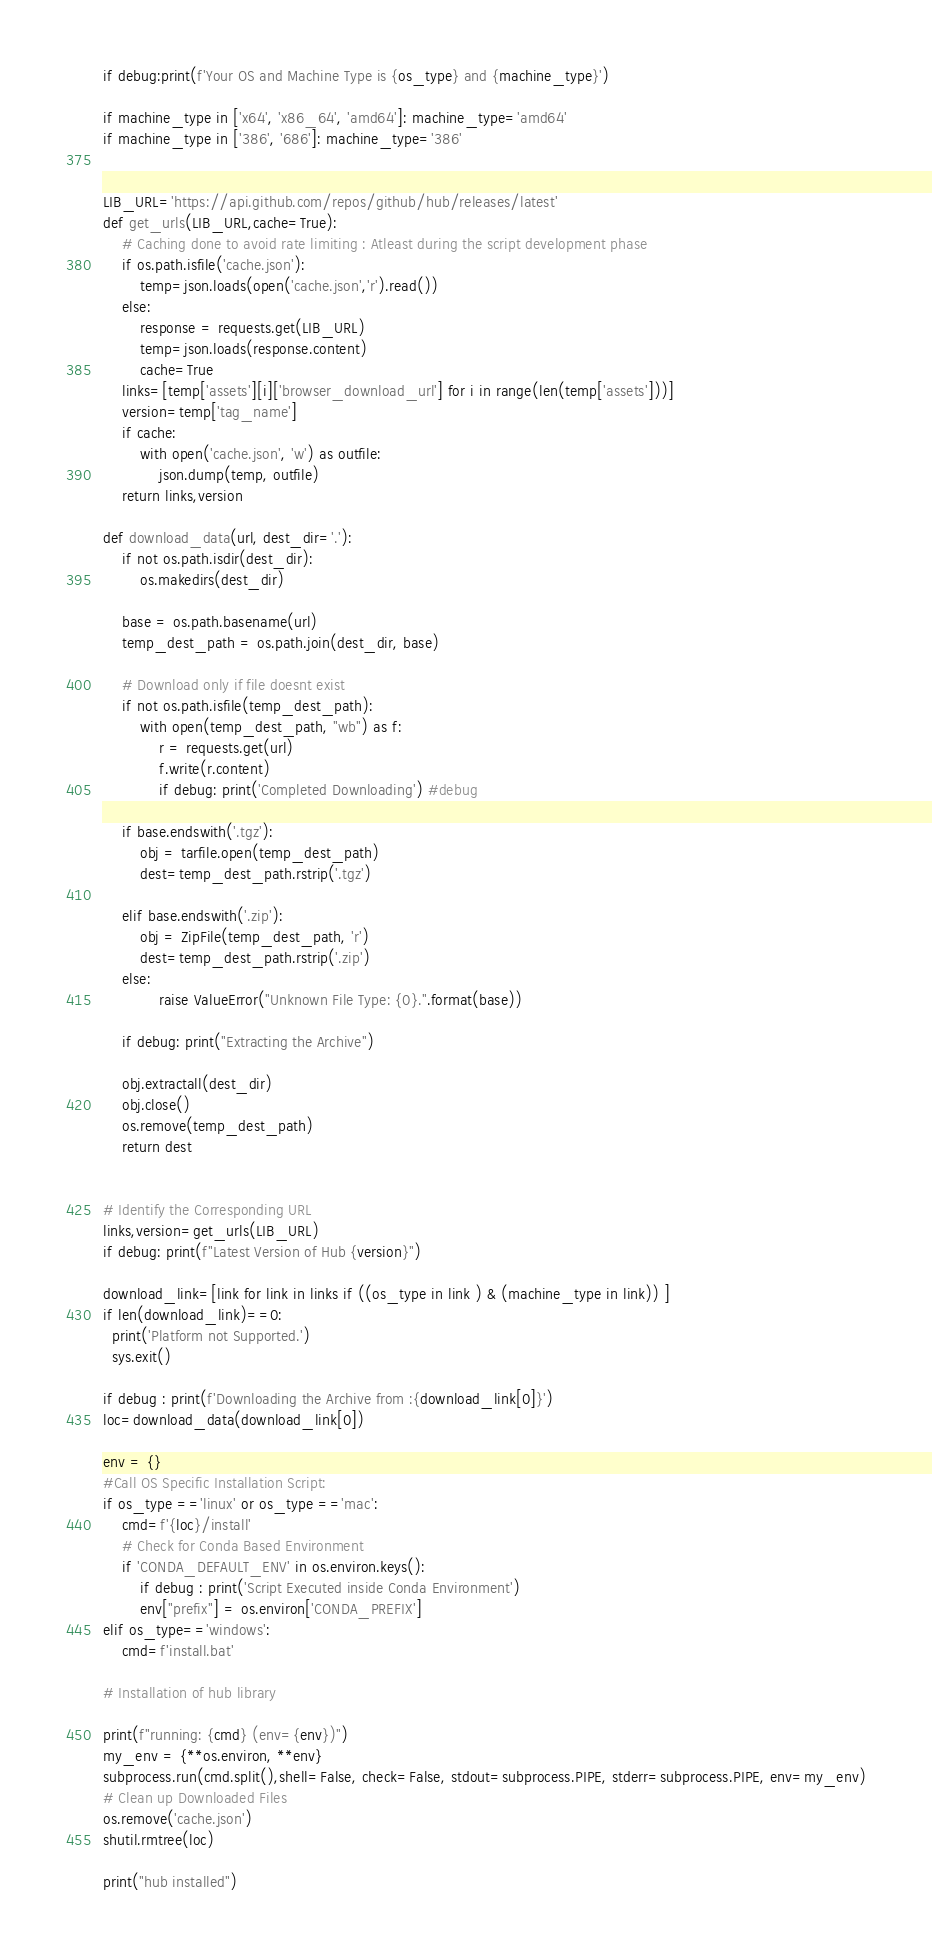<code> <loc_0><loc_0><loc_500><loc_500><_Python_>
if debug:print(f'Your OS and Machine Type is {os_type} and {machine_type}')

if machine_type in ['x64', 'x86_64', 'amd64']: machine_type='amd64'
if machine_type in ['386', '686']: machine_type='386'


LIB_URL='https://api.github.com/repos/github/hub/releases/latest'
def get_urls(LIB_URL,cache=True):
    # Caching done to avoid rate limiting : Atleast during the script development phase
    if os.path.isfile('cache.json'):
        temp=json.loads(open('cache.json','r').read())
    else:
        response = requests.get(LIB_URL)
        temp=json.loads(response.content)
        cache=True
    links=[temp['assets'][i]['browser_download_url'] for i in range(len(temp['assets']))]
    version=temp['tag_name']
    if cache:
        with open('cache.json', 'w') as outfile:
            json.dump(temp, outfile)
    return links,version

def download_data(url, dest_dir='.'):
    if not os.path.isdir(dest_dir):
        os.makedirs(dest_dir)

    base = os.path.basename(url)
    temp_dest_path = os.path.join(dest_dir, base)

    # Download only if file doesnt exist
    if not os.path.isfile(temp_dest_path):
        with open(temp_dest_path, "wb") as f:
            r = requests.get(url)
            f.write(r.content)
            if debug: print('Completed Downloading') #debug

    if base.endswith('.tgz'):
        obj = tarfile.open(temp_dest_path)
        dest=temp_dest_path.rstrip('.tgz')

    elif base.endswith('.zip'):
        obj = ZipFile(temp_dest_path, 'r')
        dest=temp_dest_path.rstrip('.zip')
    else:
            raise ValueError("Unknown File Type: {0}.".format(base))

    if debug: print("Extracting the Archive")

    obj.extractall(dest_dir)
    obj.close()
    os.remove(temp_dest_path)
    return dest


# Identify the Corresponding URL
links,version=get_urls(LIB_URL)
if debug: print(f"Latest Version of Hub {version}")

download_link=[link for link in links if ((os_type in link ) & (machine_type in link)) ]
if len(download_link)==0:
  print('Platform not Supported.')
  sys.exit()

if debug : print(f'Downloading the Archive from :{download_link[0]}')
loc=download_data(download_link[0])

env = {}
#Call OS Specific Installation Script:
if os_type =='linux' or os_type =='mac':
    cmd=f'{loc}/install'
    # Check for Conda Based Environment
    if 'CONDA_DEFAULT_ENV' in os.environ.keys():
        if debug : print('Script Executed inside Conda Environment')
        env["prefix"] = os.environ['CONDA_PREFIX']
elif os_type=='windows':
    cmd=f'install.bat'

# Installation of hub library

print(f"running: {cmd} (env={env})")
my_env = {**os.environ, **env}
subprocess.run(cmd.split(),shell=False, check=False, stdout=subprocess.PIPE, stderr=subprocess.PIPE, env=my_env)
# Clean up Downloaded Files
os.remove('cache.json')
shutil.rmtree(loc)

print("hub installed")
</code> 